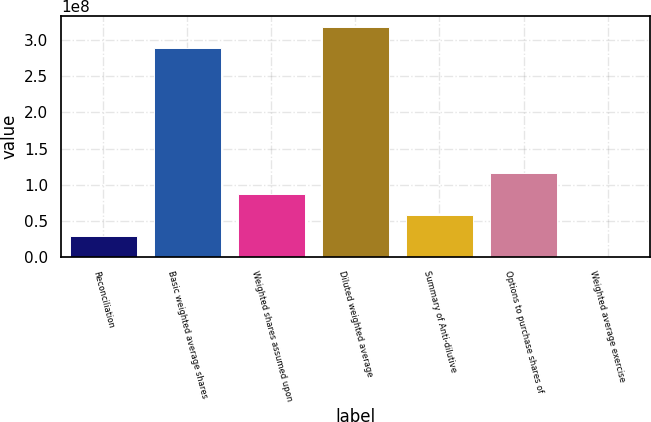Convert chart. <chart><loc_0><loc_0><loc_500><loc_500><bar_chart><fcel>Reconciliation<fcel>Basic weighted average shares<fcel>Weighted shares assumed upon<fcel>Diluted weighted average<fcel>Summary of Anti-dilutive<fcel>Options to purchase shares of<fcel>Weighted average exercise<nl><fcel>2.89158e+07<fcel>2.8895e+08<fcel>8.67473e+07<fcel>3.17865e+08<fcel>5.78315e+07<fcel>1.15663e+08<fcel>50.09<nl></chart> 